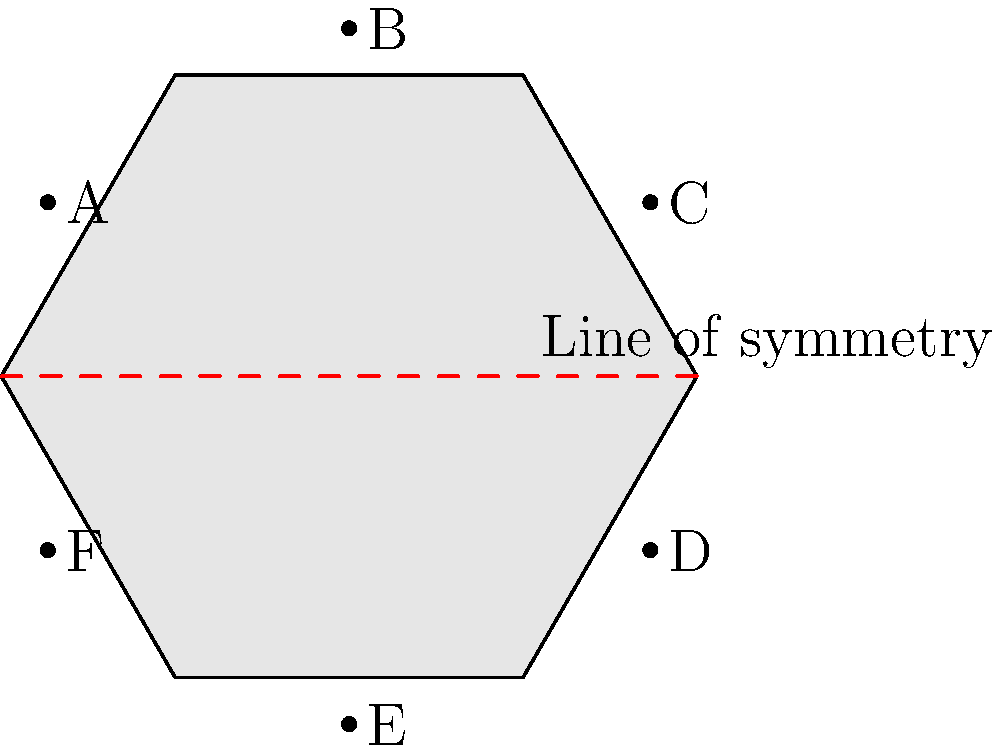In the design of a modular space station component shown above, a line of symmetry is indicated. If point A is reflected across this line of symmetry, which point will it coincide with? To determine which point A will coincide with when reflected across the line of symmetry, we need to follow these steps:

1. Understand the concept of reflection symmetry:
   - In reflection symmetry, each point on one side of the line of symmetry has a corresponding point on the other side.
   - The line of symmetry acts as a mirror, and the distance from any point to the line is equal to the distance from its reflection to the line.

2. Identify the line of symmetry:
   - In this hexagonal component, the line of symmetry is the horizontal line passing through the center.

3. Locate point A:
   - Point A is on the upper-left vertex of the hexagon.

4. Find the corresponding point on the opposite side of the line of symmetry:
   - The point directly opposite to A, equidistant from the line of symmetry, is point D.

5. Verify the reflection:
   - If we were to fold the hexagon along the line of symmetry, point A would indeed coincide with point D.

Therefore, when point A is reflected across the given line of symmetry, it will coincide with point D.
Answer: D 